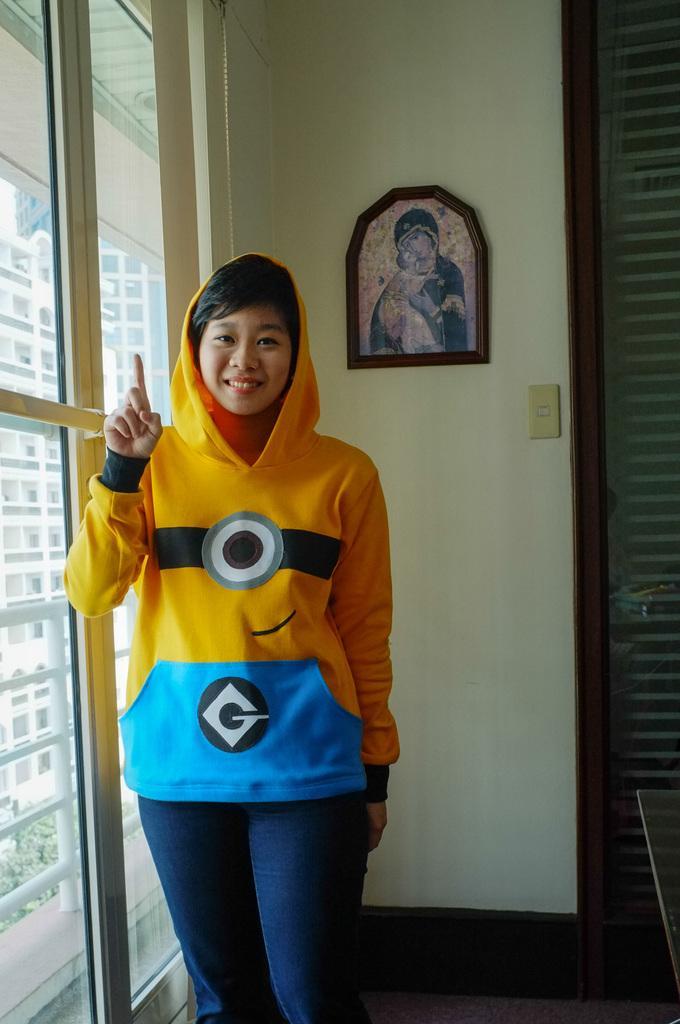How would you summarize this image in a sentence or two? In this image there is a person showing index finger is standing beside the glass wall, also there is a photo frame on the wall and a view of building from the glass wall. 